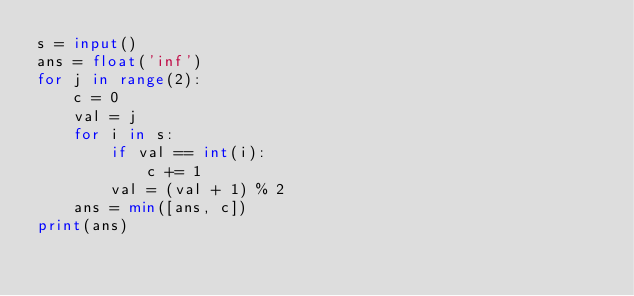<code> <loc_0><loc_0><loc_500><loc_500><_Python_>s = input()
ans = float('inf')
for j in range(2):
    c = 0
    val = j
    for i in s:
        if val == int(i):
            c += 1
        val = (val + 1) % 2
    ans = min([ans, c])
print(ans)</code> 